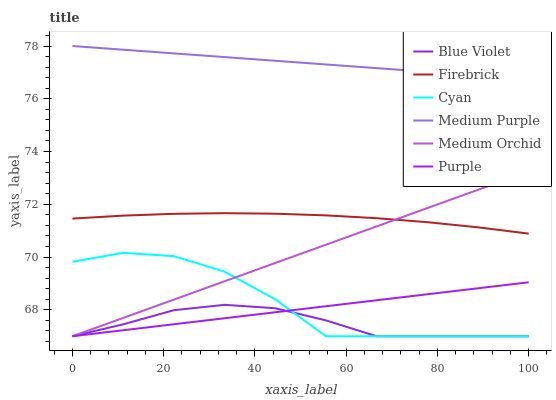Does Blue Violet have the minimum area under the curve?
Answer yes or no. Yes. Does Medium Purple have the maximum area under the curve?
Answer yes or no. Yes. Does Firebrick have the minimum area under the curve?
Answer yes or no. No. Does Firebrick have the maximum area under the curve?
Answer yes or no. No. Is Purple the smoothest?
Answer yes or no. Yes. Is Cyan the roughest?
Answer yes or no. Yes. Is Firebrick the smoothest?
Answer yes or no. No. Is Firebrick the roughest?
Answer yes or no. No. Does Purple have the lowest value?
Answer yes or no. Yes. Does Firebrick have the lowest value?
Answer yes or no. No. Does Medium Purple have the highest value?
Answer yes or no. Yes. Does Firebrick have the highest value?
Answer yes or no. No. Is Purple less than Firebrick?
Answer yes or no. Yes. Is Medium Purple greater than Firebrick?
Answer yes or no. Yes. Does Firebrick intersect Medium Orchid?
Answer yes or no. Yes. Is Firebrick less than Medium Orchid?
Answer yes or no. No. Is Firebrick greater than Medium Orchid?
Answer yes or no. No. Does Purple intersect Firebrick?
Answer yes or no. No. 